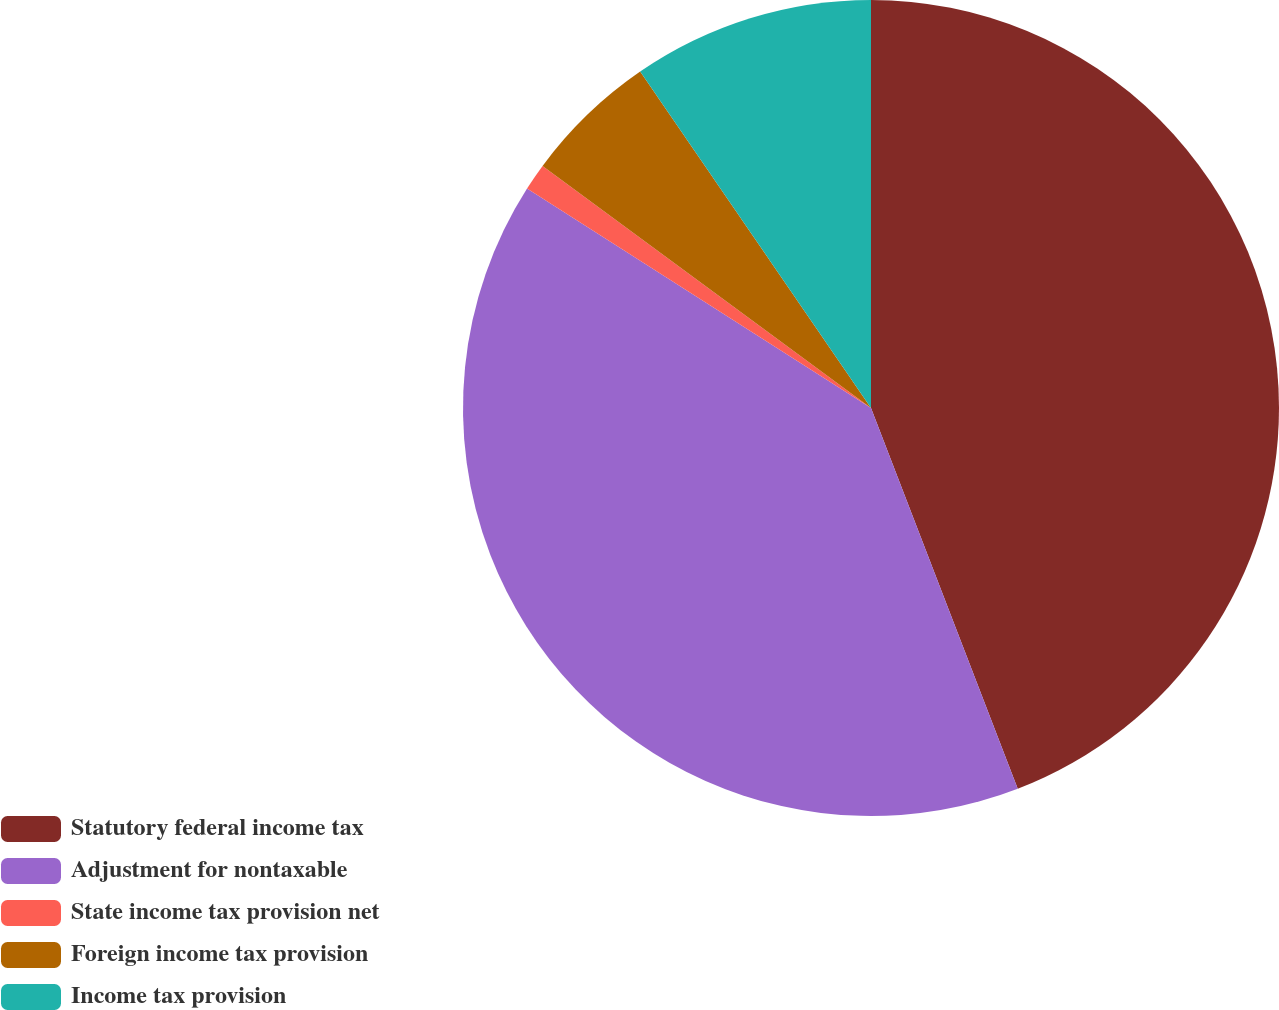Convert chart to OTSL. <chart><loc_0><loc_0><loc_500><loc_500><pie_chart><fcel>Statutory federal income tax<fcel>Adjustment for nontaxable<fcel>State income tax provision net<fcel>Foreign income tax provision<fcel>Income tax provision<nl><fcel>44.14%<fcel>39.89%<fcel>1.07%<fcel>5.32%<fcel>9.57%<nl></chart> 